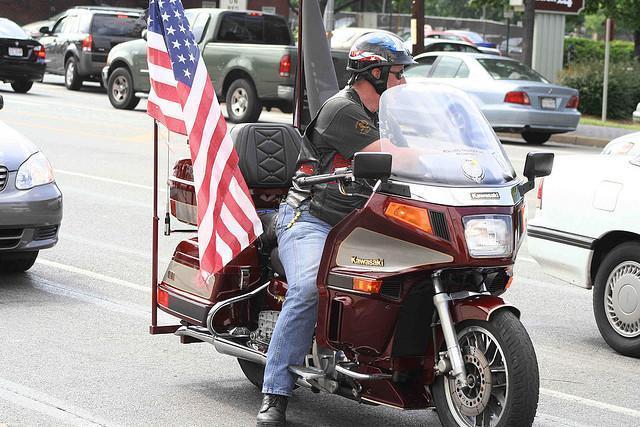How many people can sit on the bike?
Give a very brief answer. 2. How many trucks are there?
Give a very brief answer. 1. How many cars are there?
Give a very brief answer. 5. 